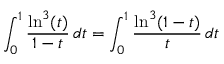<formula> <loc_0><loc_0><loc_500><loc_500>\int _ { 0 } ^ { 1 } \frac { \ln ^ { 3 } ( t ) } { 1 - t } \, d t = \int _ { 0 } ^ { 1 } \frac { \ln ^ { 3 } ( 1 - t ) } { t } \, d t</formula> 